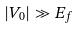Convert formula to latex. <formula><loc_0><loc_0><loc_500><loc_500>| V _ { 0 } | \gg E _ { f }</formula> 